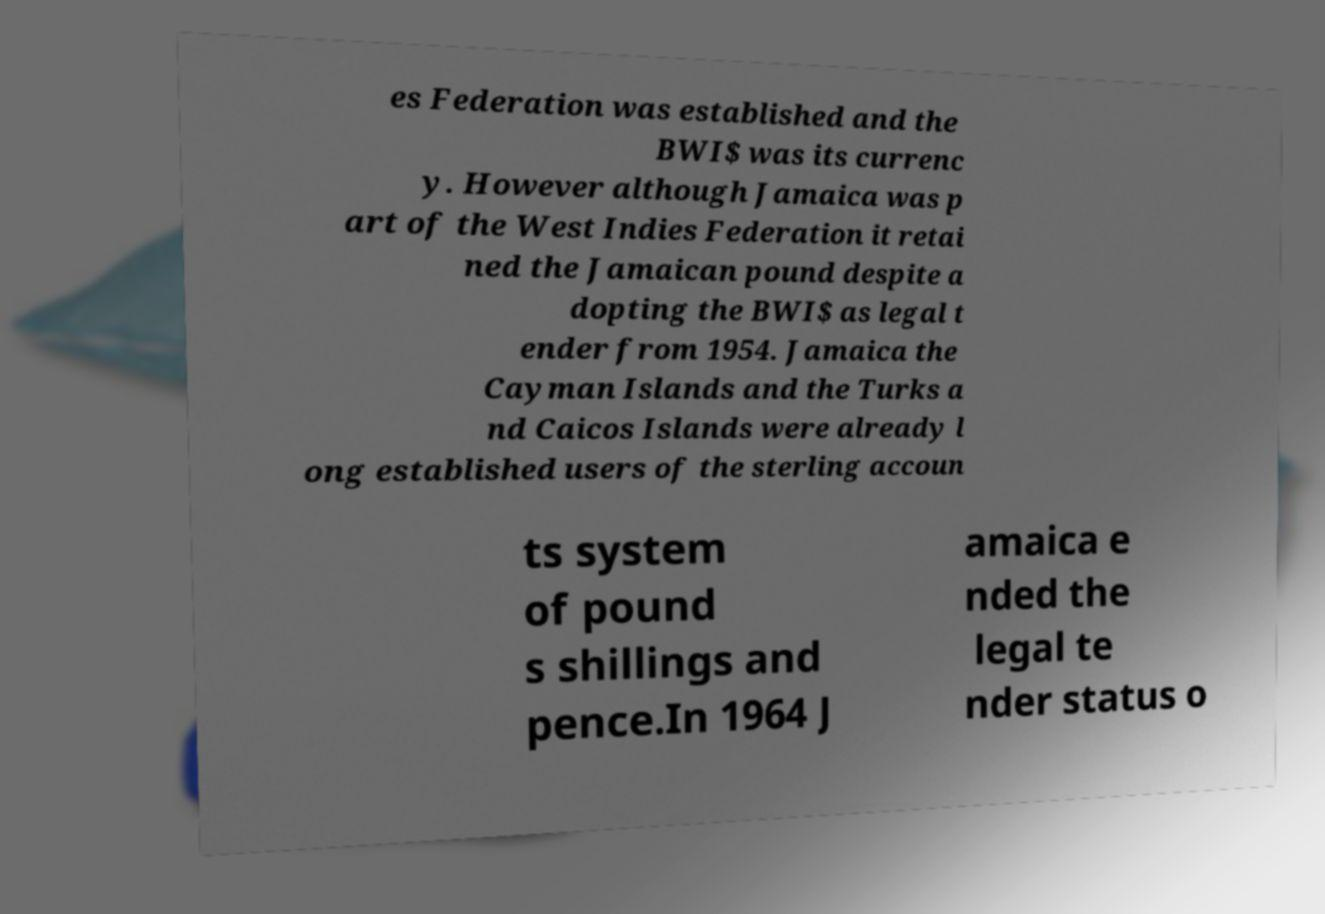For documentation purposes, I need the text within this image transcribed. Could you provide that? es Federation was established and the BWI$ was its currenc y. However although Jamaica was p art of the West Indies Federation it retai ned the Jamaican pound despite a dopting the BWI$ as legal t ender from 1954. Jamaica the Cayman Islands and the Turks a nd Caicos Islands were already l ong established users of the sterling accoun ts system of pound s shillings and pence.In 1964 J amaica e nded the legal te nder status o 